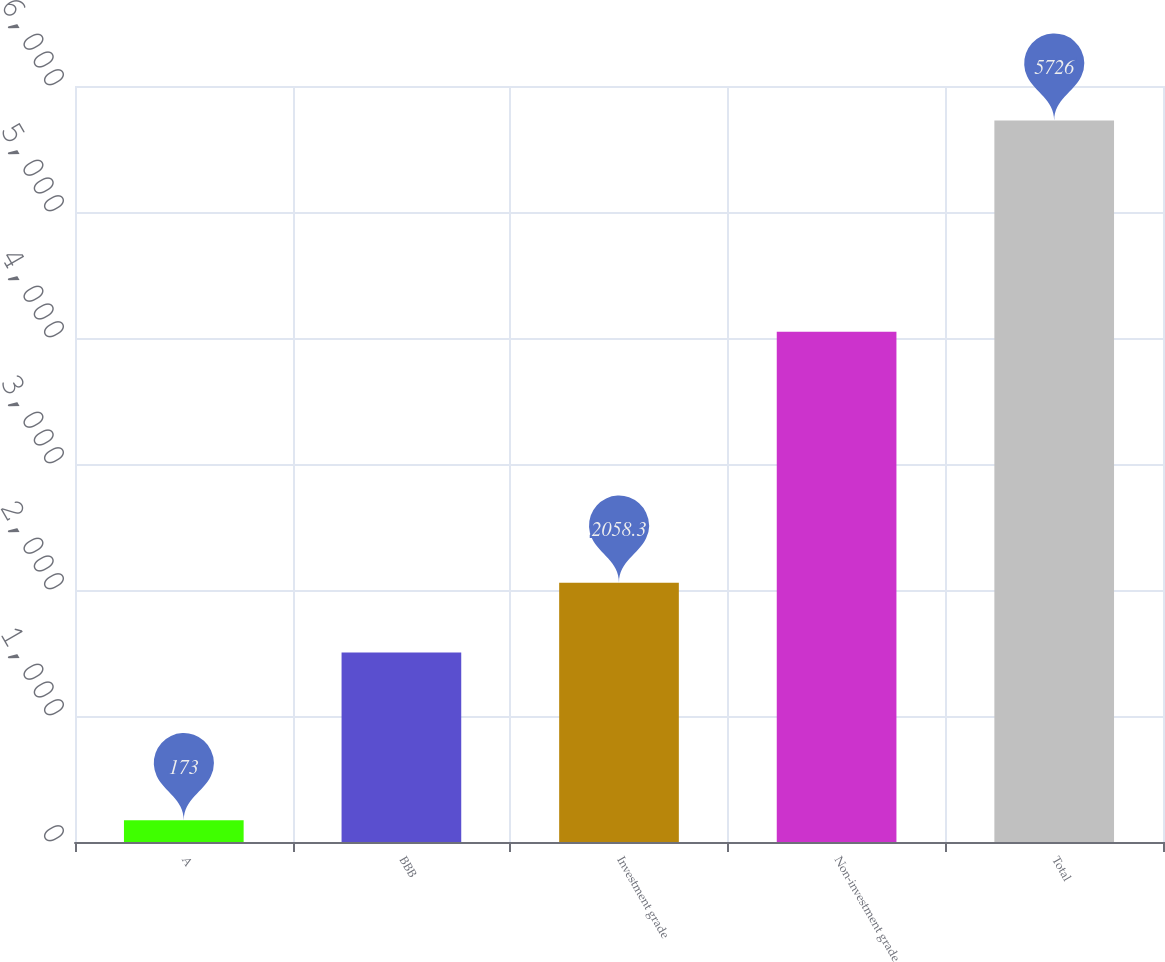<chart> <loc_0><loc_0><loc_500><loc_500><bar_chart><fcel>A<fcel>BBB<fcel>Investment grade<fcel>Non-investment grade<fcel>Total<nl><fcel>173<fcel>1503<fcel>2058.3<fcel>4050<fcel>5726<nl></chart> 